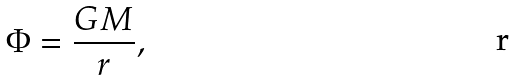Convert formula to latex. <formula><loc_0><loc_0><loc_500><loc_500>\Phi = \frac { G M } { r } ,</formula> 